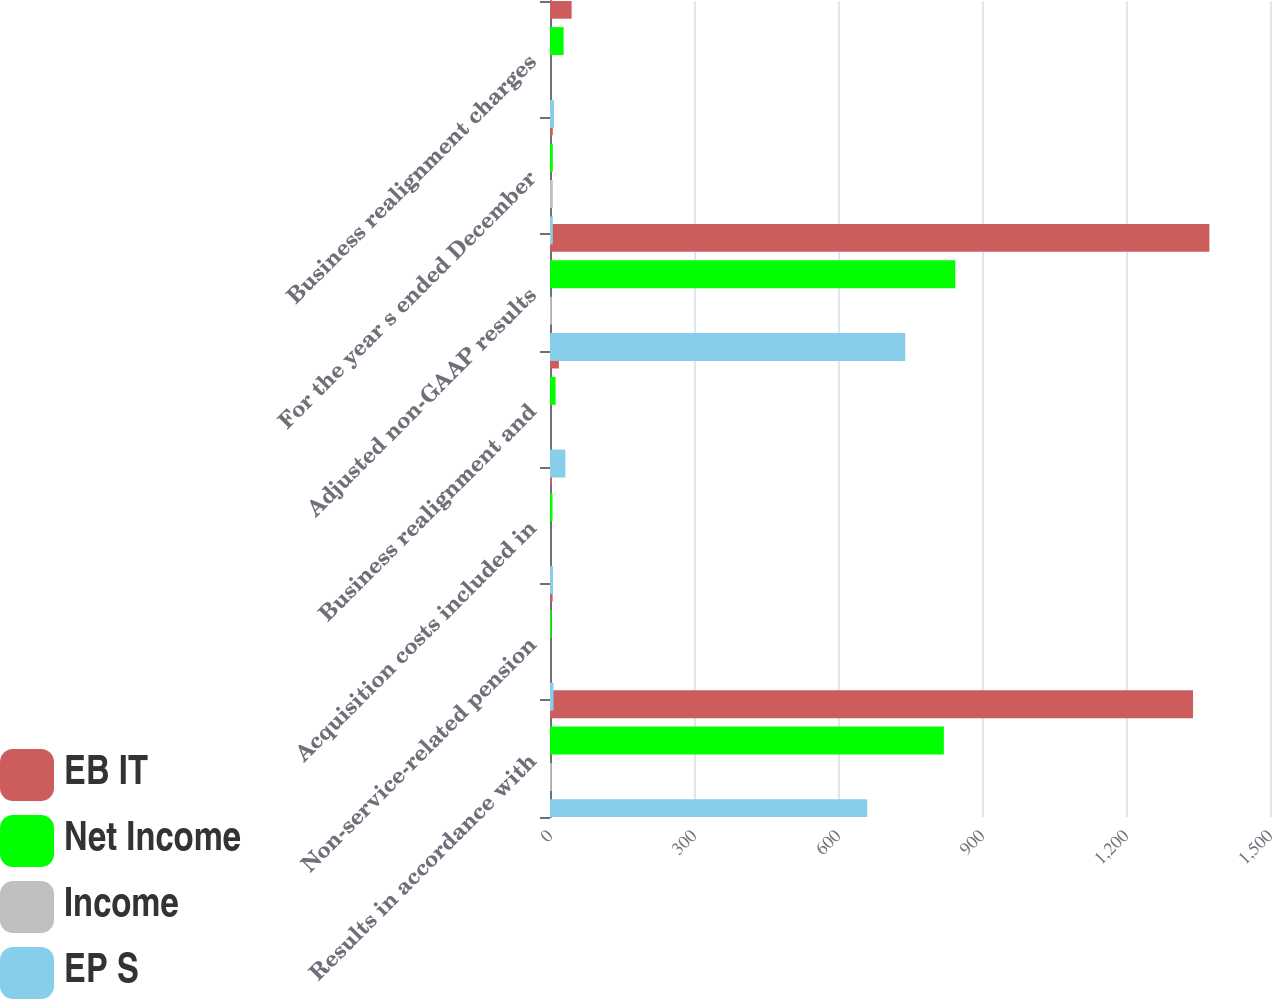<chart> <loc_0><loc_0><loc_500><loc_500><stacked_bar_chart><ecel><fcel>Results in accordance with<fcel>Non-service-related pension<fcel>Acquisition costs included in<fcel>Business realignment and<fcel>Adjusted non-GAAP results<fcel>For the year s ended December<fcel>Business realignment charges<nl><fcel>EB IT<fcel>1339.7<fcel>5.5<fcel>3.8<fcel>18.6<fcel>1373.7<fcel>5.85<fcel>45.1<nl><fcel>Net Income<fcel>820.5<fcel>3.3<fcel>5.2<fcel>11.6<fcel>844.3<fcel>5.85<fcel>28.4<nl><fcel>Income<fcel>3.61<fcel>0.01<fcel>0.03<fcel>0.05<fcel>3.72<fcel>5.85<fcel>0.12<nl><fcel>EP S<fcel>660.9<fcel>7.4<fcel>6.2<fcel>31.9<fcel>740<fcel>5.85<fcel>8.4<nl></chart> 